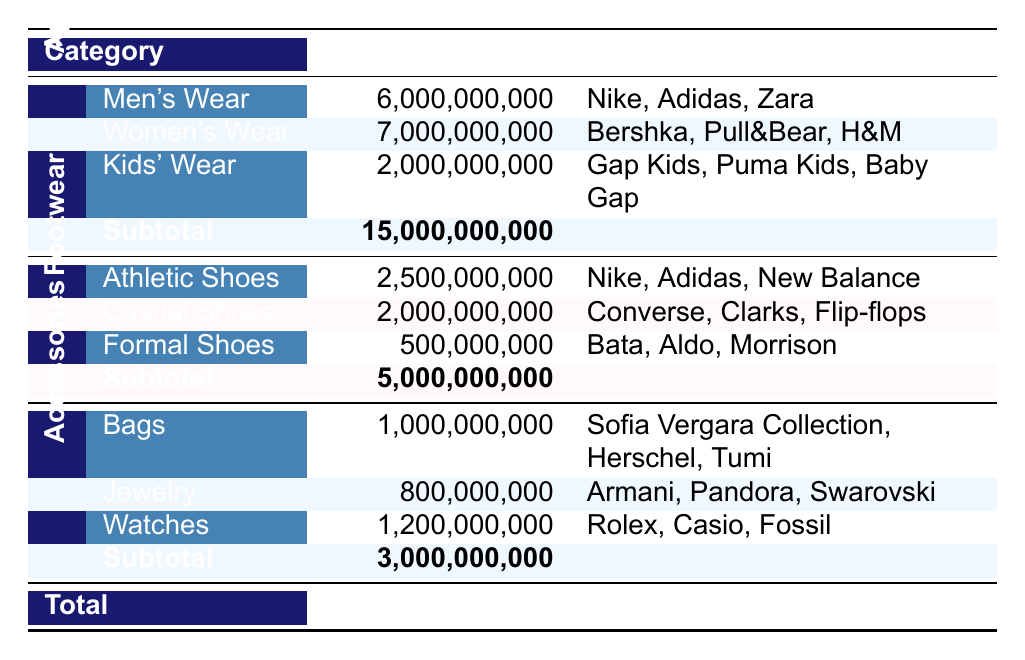What are the total sales for Women's Wear in 2022? The table indicates that the total sales for Women's Wear are specifically listed under the Apparel category, showing 7,000,000,000 COP.
Answer: 7,000,000,000 COP Which category had the highest total sales in 2022? By reviewing the total sales figures in the table, Apparel has a total of 15,000,000,000 COP, the highest compared to Footwear (5,000,000,000 COP) and Accessories (3,000,000,000 COP).
Answer: Apparel Is it true that Formal Shoes generated more sales than Kids' Wear? The total sales for Formal Shoes is 500,000,000 COP, while Kids' Wear has total sales of 2,000,000,000 COP. Therefore, it is false that Formal Shoes generated more sales than Kids' Wear.
Answer: No What is the total sales of Accessories compared to the sales of Kids' Wear? The total sales for Accessories is 3,000,000,000 COP, while Kids' Wear totals 2,000,000,000 COP. By comparing these figures, Accessories outsell Kids' Wear by 1,000,000,000 COP.
Answer: Accessories outsell Kids' Wear by 1,000,000,000 COP Which top brand is associated with Athletic Shoes? The table lists the top brands for Athletic Shoes under Footwear, which are Nike, Adidas, and New Balance. Thus, Nike is one of the top brands associated with Athletic Shoes.
Answer: Nike 